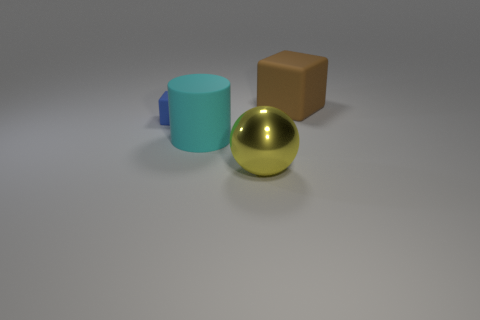There is another brown object that is the same shape as the tiny object; what material is it?
Make the answer very short. Rubber. Are there any gray cubes that have the same material as the large brown block?
Keep it short and to the point. No. How many small gray rubber blocks are there?
Ensure brevity in your answer.  0. Are the tiny object and the big thing that is in front of the big rubber cylinder made of the same material?
Provide a short and direct response. No. What number of rubber cubes have the same color as the metal sphere?
Ensure brevity in your answer.  0. How big is the ball?
Your response must be concise. Large. Do the blue thing and the big thing that is right of the big yellow shiny ball have the same shape?
Offer a terse response. Yes. There is a big block that is the same material as the big cylinder; what is its color?
Offer a very short reply. Brown. There is a matte object that is to the right of the big yellow metal ball; what is its size?
Give a very brief answer. Large. Is the number of large brown matte objects that are behind the large cube less than the number of tiny matte balls?
Your answer should be compact. No. 